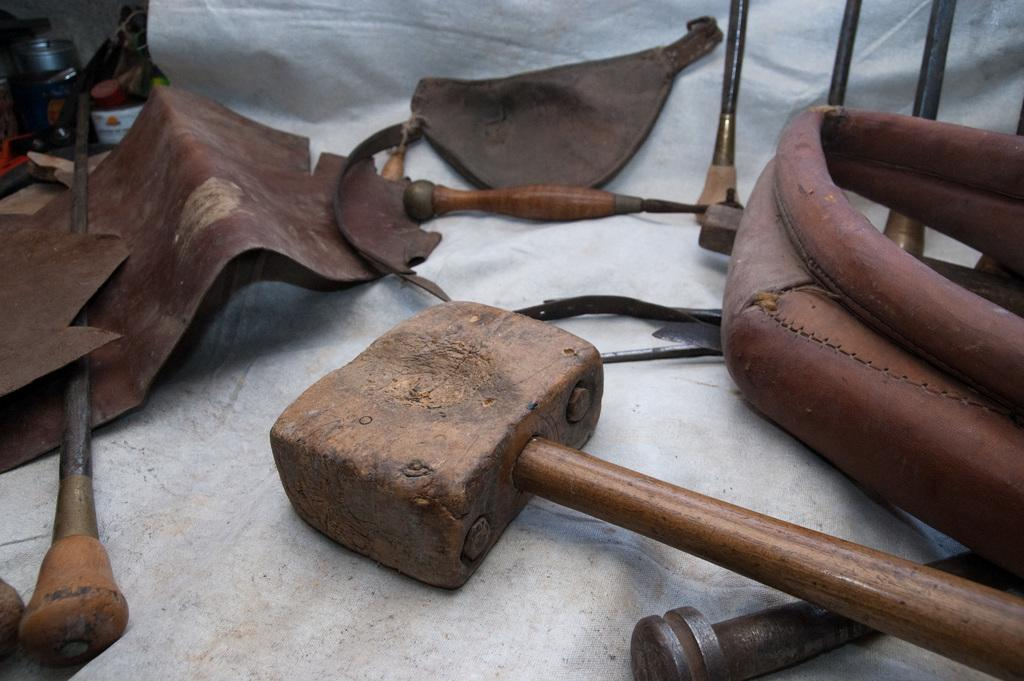What objects can be seen in the image related to music or craftsmanship? There are instruments and a wooden hammer in the image. What material is used for some of the pieces in the image? There are leather pieces in the image. Can you hear someone sneezing in the image? There is no indication of sound or sneezing in the image, as it is a still image. Is there any popcorn visible in the image? There is no popcorn present in the image. 